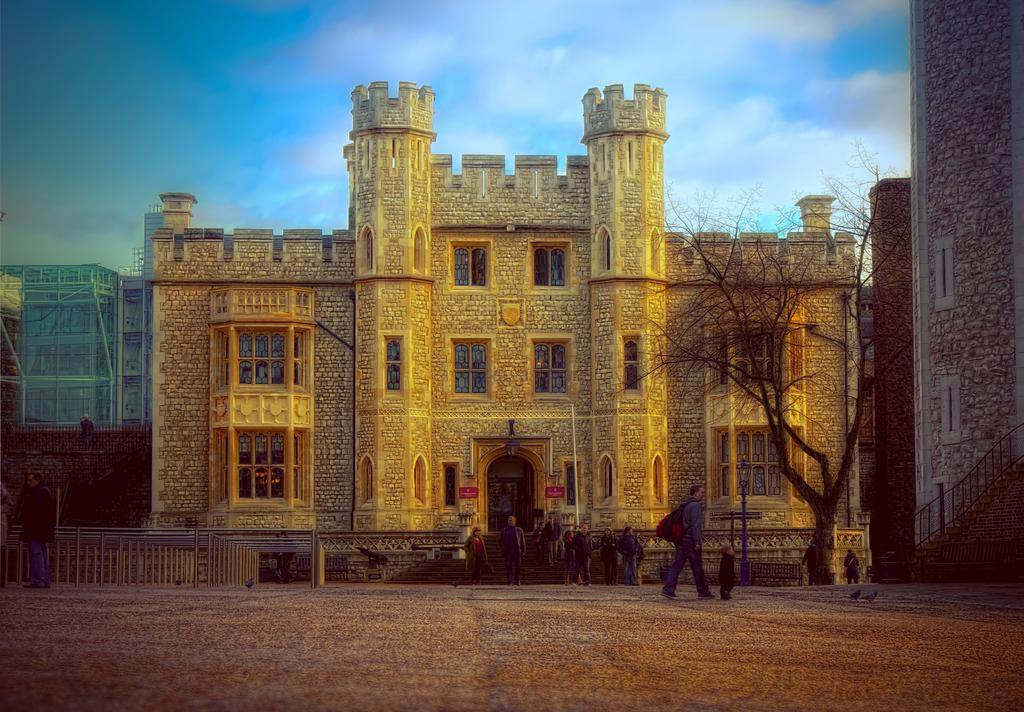What type of structures can be seen in the image? There are buildings in the image. What is located in front of the building? There is a tree in front of the building. What type of materials are present in the image? Metal rods and poles are present in the image. Who or what else can be seen in the image? There is a group of people and birds visible in the image. Where is the market located in the image? There is no mention of a market in the image. 